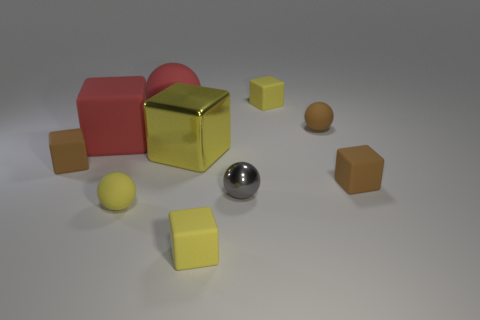Does the large matte cube have the same color as the large sphere?
Ensure brevity in your answer.  Yes. There is a sphere that is the same color as the metallic cube; what is its material?
Keep it short and to the point. Rubber. What number of blocks are either tiny objects or small matte objects?
Your response must be concise. 4. Is the material of the yellow block behind the big yellow block the same as the big block that is on the right side of the big red sphere?
Provide a short and direct response. No. There is a metallic object that is the same size as the yellow rubber ball; what is its shape?
Your answer should be compact. Sphere. What number of other things are there of the same color as the metallic cube?
Give a very brief answer. 3. How many yellow things are big metal blocks or large rubber cubes?
Your answer should be compact. 1. There is a brown object that is left of the tiny yellow sphere; is it the same shape as the object that is behind the red matte ball?
Ensure brevity in your answer.  Yes. How many other objects are there of the same material as the small gray thing?
Your answer should be very brief. 1. Are there any tiny brown things that are on the left side of the matte block to the right of the small brown matte object behind the big yellow shiny block?
Your answer should be very brief. Yes. 